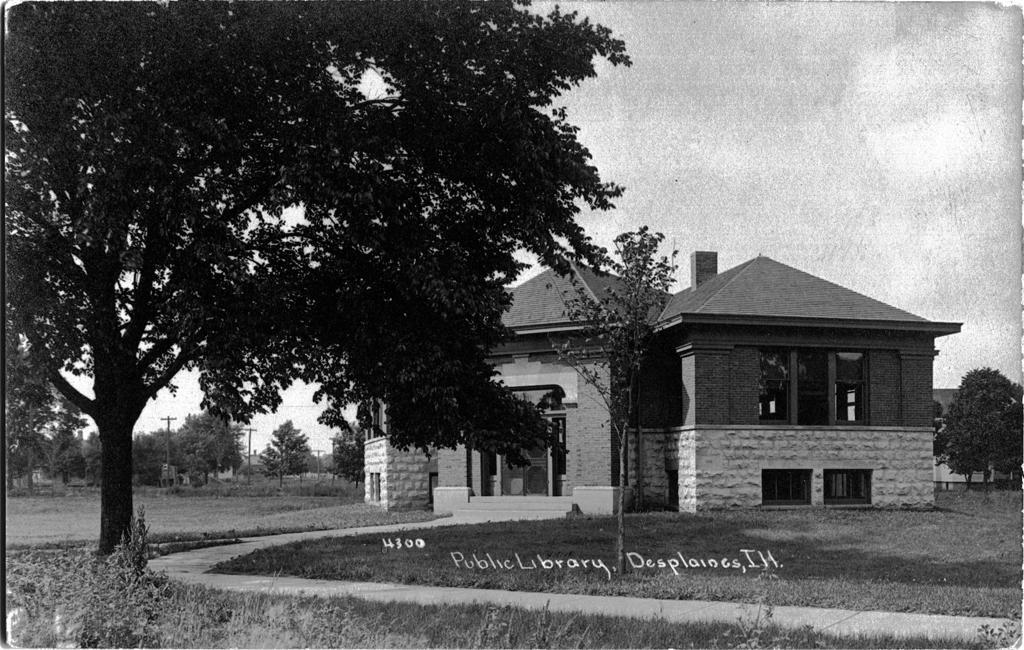In one or two sentences, can you explain what this image depicts? In this given picture, We can see couple of trees, ground, a electrical poles, sky and a few houses and there is a root which leads to house. 